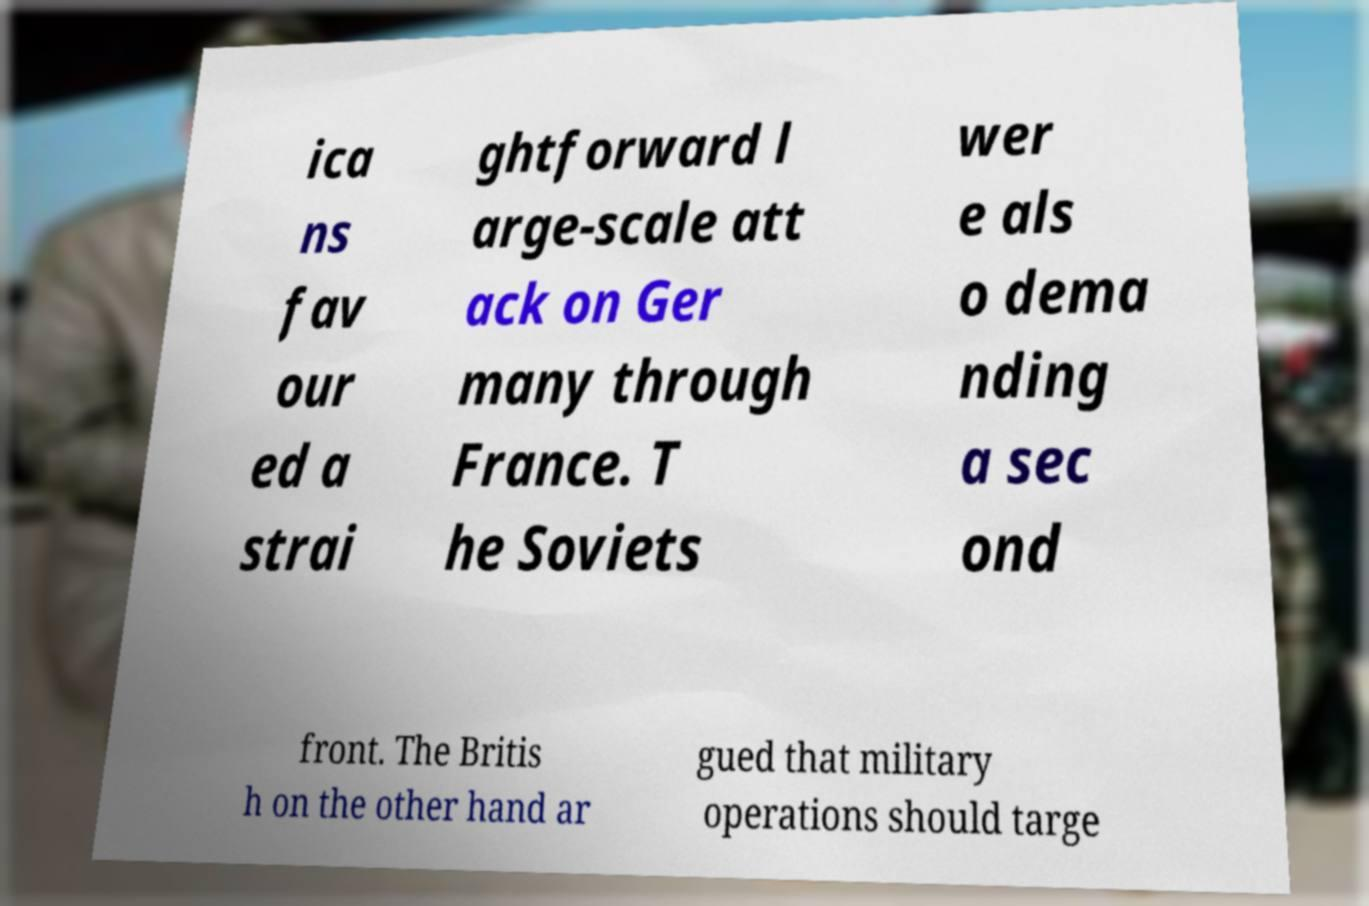Can you accurately transcribe the text from the provided image for me? ica ns fav our ed a strai ghtforward l arge-scale att ack on Ger many through France. T he Soviets wer e als o dema nding a sec ond front. The Britis h on the other hand ar gued that military operations should targe 